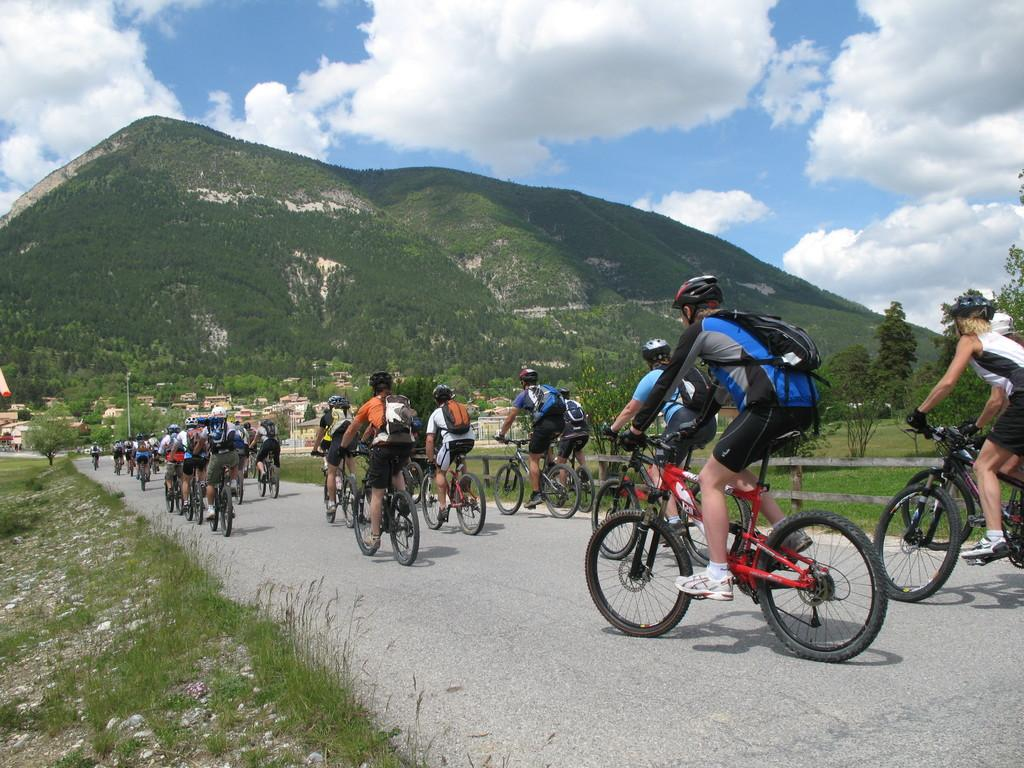What are the people in the image doing? The groups of people are riding bicycles on the road. What type of terrain can be seen in the image? There is grass visible in the image. What geographical feature is present in the image? There is a mountain in the image. What type of structures can be seen in the image? There are houses in the image. What type of vegetation is present in the image? There are trees in the image. What is visible in the sky in the image? Clouds are visible in the sky. What type of calendar is hanging on the mountain in the image? There is no calendar present in the image, and the mountain is not a location where a calendar would typically be hung. 